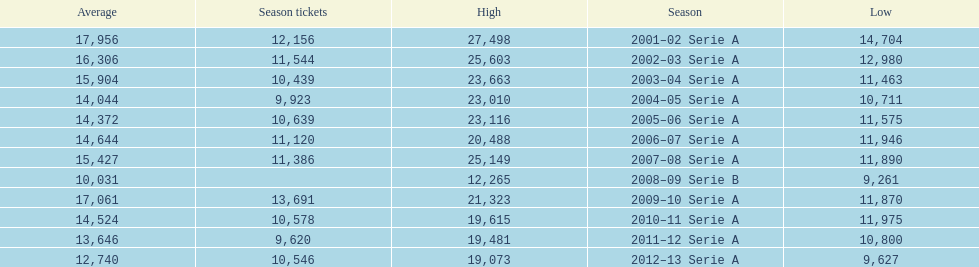Parse the table in full. {'header': ['Average', 'Season tickets', 'High', 'Season', 'Low'], 'rows': [['17,956', '12,156', '27,498', '2001–02 Serie A', '14,704'], ['16,306', '11,544', '25,603', '2002–03 Serie A', '12,980'], ['15,904', '10,439', '23,663', '2003–04 Serie A', '11,463'], ['14,044', '9,923', '23,010', '2004–05 Serie A', '10,711'], ['14,372', '10,639', '23,116', '2005–06 Serie A', '11,575'], ['14,644', '11,120', '20,488', '2006–07 Serie A', '11,946'], ['15,427', '11,386', '25,149', '2007–08 Serie A', '11,890'], ['10,031', '', '12,265', '2008–09 Serie B', '9,261'], ['17,061', '13,691', '21,323', '2009–10 Serie A', '11,870'], ['14,524', '10,578', '19,615', '2010–11 Serie A', '11,975'], ['13,646', '9,620', '19,481', '2011–12 Serie A', '10,800'], ['12,740', '10,546', '19,073', '2012–13 Serie A', '9,627']]} How many seasons had average attendance of at least 15,000 at the stadio ennio tardini? 5. 